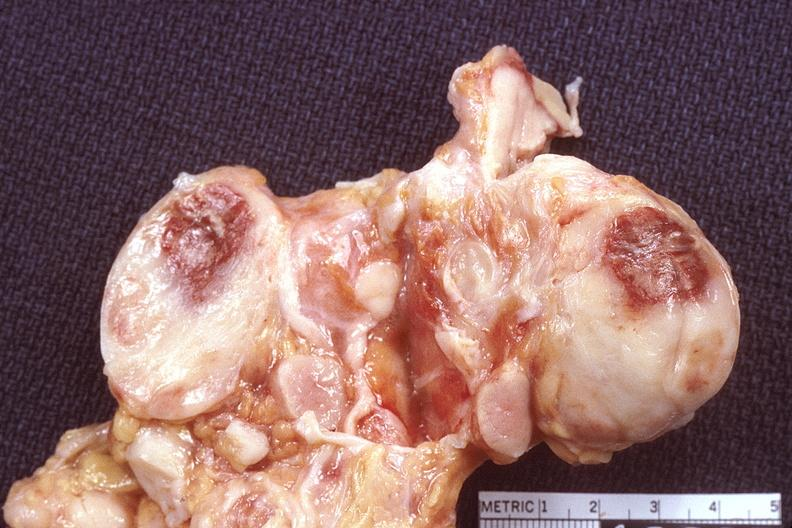what does this image show?
Answer the question using a single word or phrase. Lymph nodes 